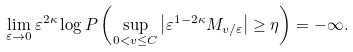Convert formula to latex. <formula><loc_0><loc_0><loc_500><loc_500>\lim _ { \varepsilon \to 0 } \varepsilon ^ { 2 \kappa } \log P \left ( \sup _ { 0 < v \leq C } \left | \varepsilon ^ { 1 - 2 \kappa } M _ { v / \varepsilon } \right | \geq \eta \right ) = - \infty .</formula> 